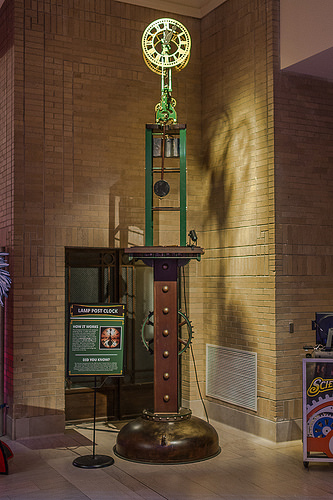<image>
Can you confirm if the sign is on the wall? No. The sign is not positioned on the wall. They may be near each other, but the sign is not supported by or resting on top of the wall. 